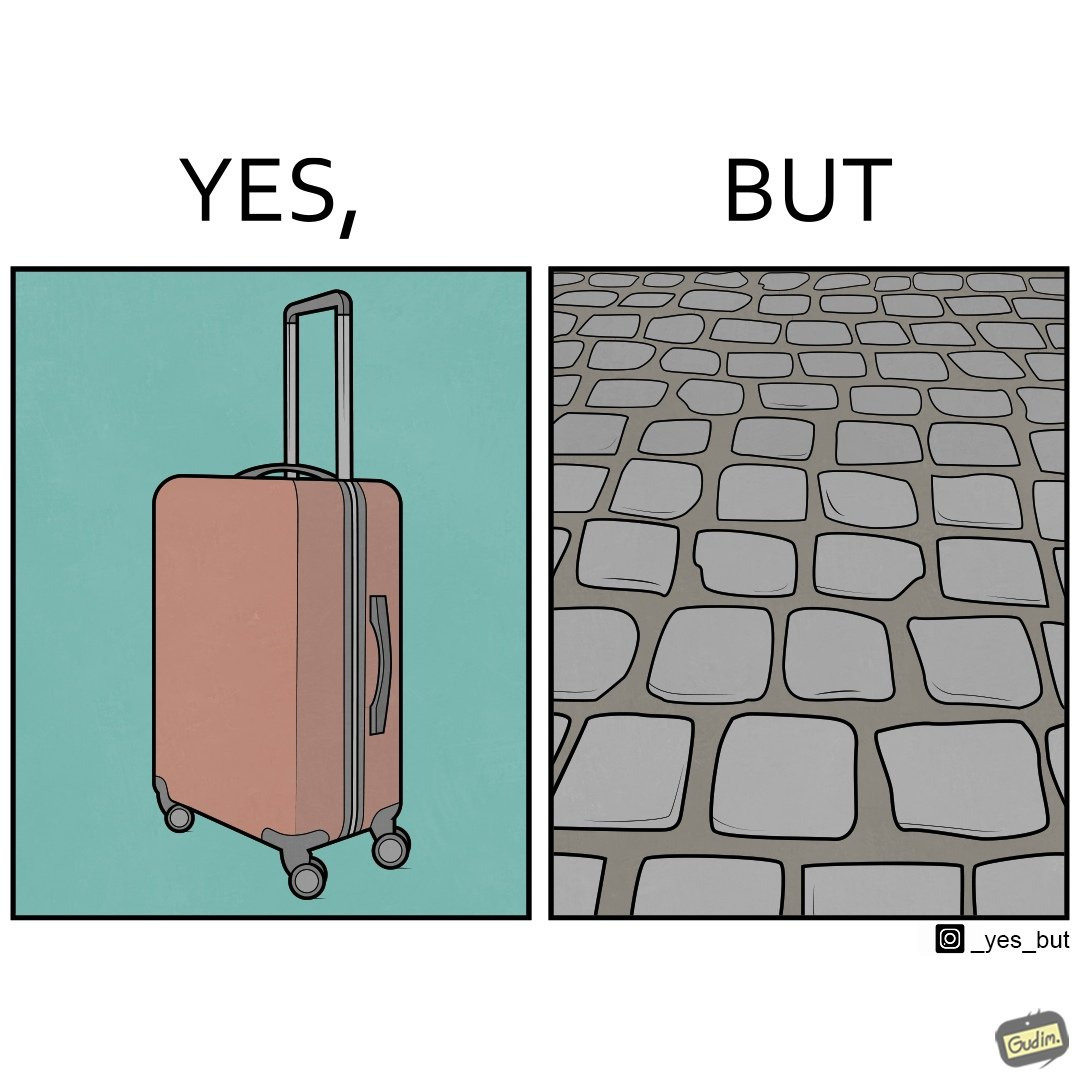Is this a satirical image? Yes, this image is satirical. 